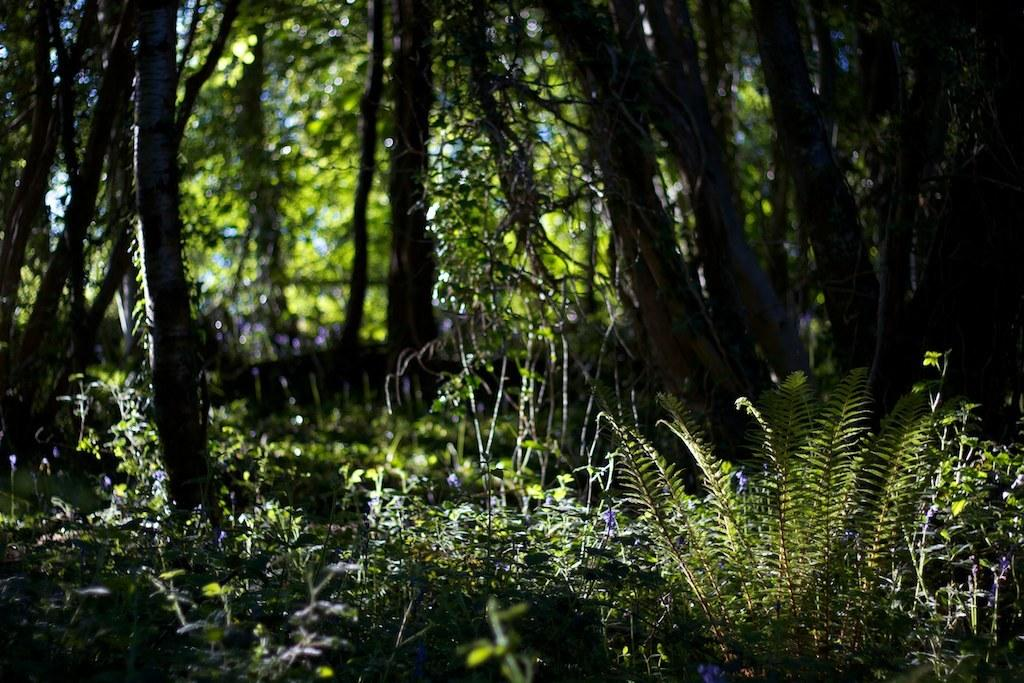What type of vegetation can be seen in the image? There are plants and trees visible in the image. What part of the trees can be seen in the image? Tree trunks are visible in the image. How would you describe the background of the image? The background of the image has a blurred view. What type of brush can be seen in the image? There is no brush present in the image. What kind of humor can be observed in the image? The image does not contain any humor, as it is a photograph of plants and trees. 